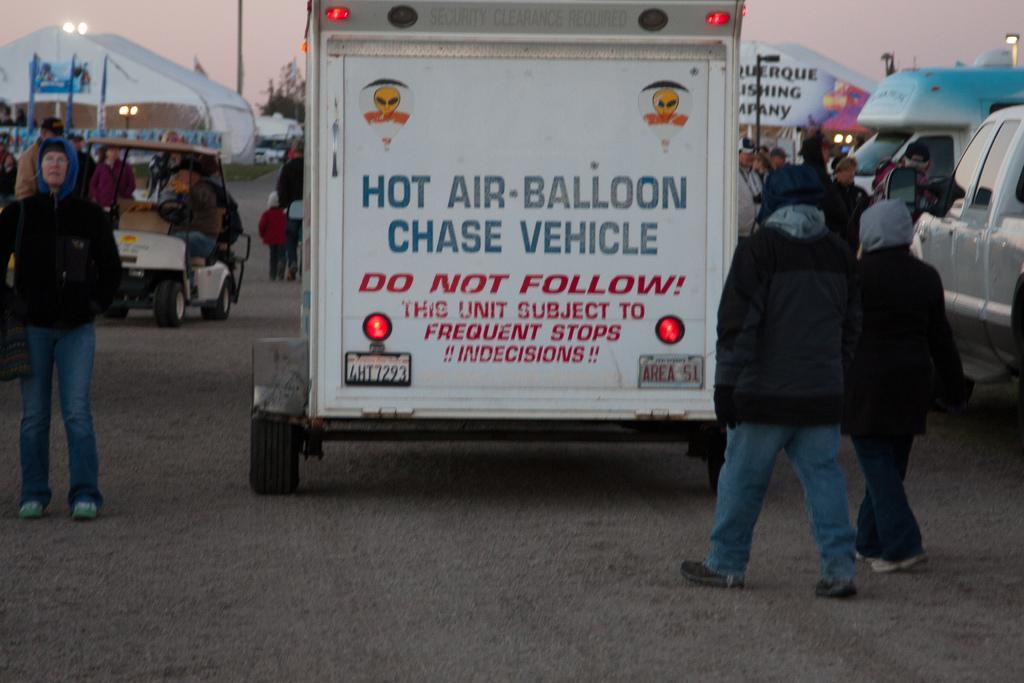How would you summarize this image in a sentence or two? In this image I can see few people and many vehicles on the road. I can see few people sitting in the vehicle. In the background I can see the poles, trees and the sky. 